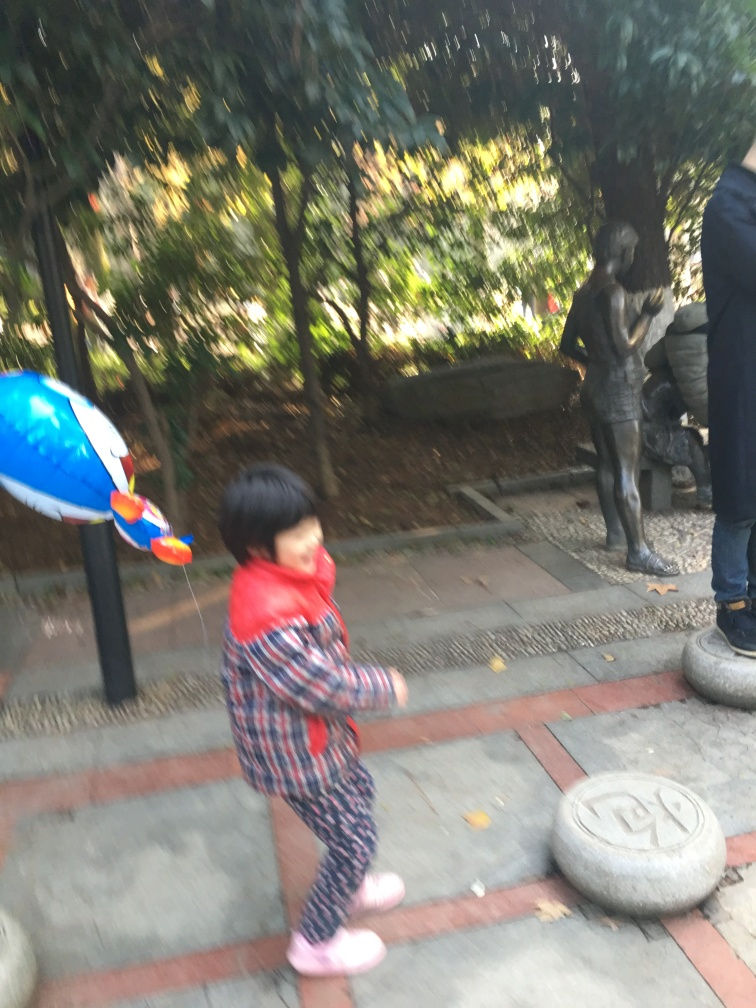What emotions or themes does the motion blur in this image potentially convey? The motion blur in this image introduces a sense of spontaneity and liveliness. It suggests the playful energy of a child at play and gives the scene an ephemeral quality, as if capturing a fleeting moment in time. This technique can also evoke a feeling of nostalgia, reminiscent of the way memories can be a bit hazy around the edges, focusing more on the emotion of the moment than on the concrete details. 